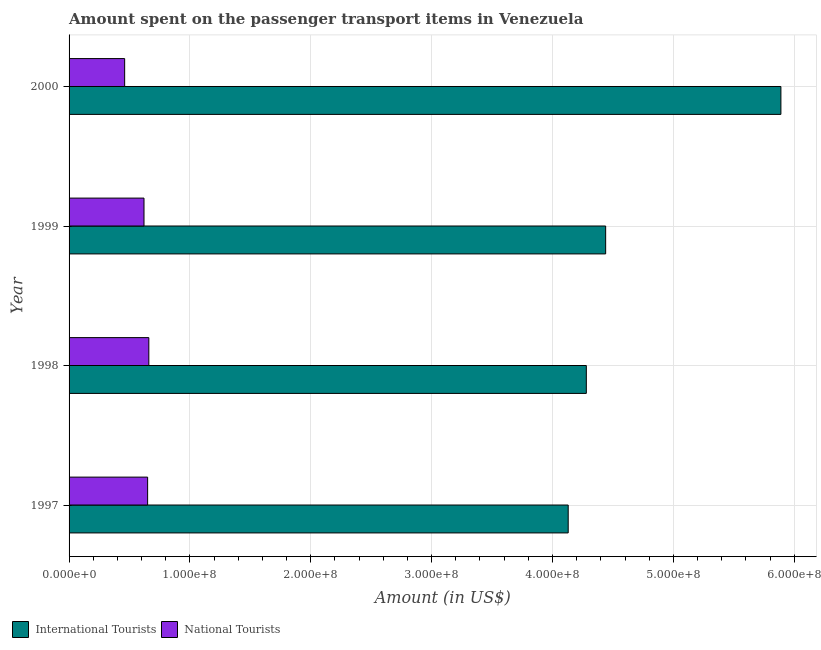How many different coloured bars are there?
Offer a very short reply. 2. How many groups of bars are there?
Your answer should be very brief. 4. Are the number of bars on each tick of the Y-axis equal?
Provide a short and direct response. Yes. How many bars are there on the 4th tick from the top?
Your answer should be very brief. 2. How many bars are there on the 2nd tick from the bottom?
Provide a short and direct response. 2. What is the label of the 2nd group of bars from the top?
Your answer should be very brief. 1999. What is the amount spent on transport items of international tourists in 2000?
Offer a terse response. 5.89e+08. Across all years, what is the maximum amount spent on transport items of national tourists?
Your response must be concise. 6.60e+07. Across all years, what is the minimum amount spent on transport items of national tourists?
Your answer should be compact. 4.60e+07. In which year was the amount spent on transport items of national tourists maximum?
Offer a terse response. 1998. In which year was the amount spent on transport items of international tourists minimum?
Your response must be concise. 1997. What is the total amount spent on transport items of national tourists in the graph?
Provide a short and direct response. 2.39e+08. What is the difference between the amount spent on transport items of national tourists in 1998 and that in 1999?
Ensure brevity in your answer.  4.00e+06. What is the difference between the amount spent on transport items of national tourists in 1997 and the amount spent on transport items of international tourists in 2000?
Your answer should be compact. -5.24e+08. What is the average amount spent on transport items of national tourists per year?
Keep it short and to the point. 5.98e+07. In the year 1997, what is the difference between the amount spent on transport items of international tourists and amount spent on transport items of national tourists?
Offer a terse response. 3.48e+08. What is the ratio of the amount spent on transport items of international tourists in 1999 to that in 2000?
Your answer should be compact. 0.75. Is the amount spent on transport items of national tourists in 1998 less than that in 1999?
Give a very brief answer. No. What is the difference between the highest and the second highest amount spent on transport items of international tourists?
Keep it short and to the point. 1.45e+08. What is the difference between the highest and the lowest amount spent on transport items of international tourists?
Your answer should be very brief. 1.76e+08. Is the sum of the amount spent on transport items of international tourists in 1999 and 2000 greater than the maximum amount spent on transport items of national tourists across all years?
Your answer should be compact. Yes. What does the 1st bar from the top in 1999 represents?
Your answer should be very brief. National Tourists. What does the 2nd bar from the bottom in 1999 represents?
Provide a succinct answer. National Tourists. How many years are there in the graph?
Keep it short and to the point. 4. Does the graph contain any zero values?
Provide a succinct answer. No. Where does the legend appear in the graph?
Your answer should be very brief. Bottom left. What is the title of the graph?
Provide a short and direct response. Amount spent on the passenger transport items in Venezuela. What is the Amount (in US$) in International Tourists in 1997?
Offer a terse response. 4.13e+08. What is the Amount (in US$) of National Tourists in 1997?
Provide a succinct answer. 6.50e+07. What is the Amount (in US$) in International Tourists in 1998?
Give a very brief answer. 4.28e+08. What is the Amount (in US$) of National Tourists in 1998?
Your response must be concise. 6.60e+07. What is the Amount (in US$) of International Tourists in 1999?
Keep it short and to the point. 4.44e+08. What is the Amount (in US$) in National Tourists in 1999?
Offer a very short reply. 6.20e+07. What is the Amount (in US$) in International Tourists in 2000?
Keep it short and to the point. 5.89e+08. What is the Amount (in US$) of National Tourists in 2000?
Your response must be concise. 4.60e+07. Across all years, what is the maximum Amount (in US$) of International Tourists?
Ensure brevity in your answer.  5.89e+08. Across all years, what is the maximum Amount (in US$) of National Tourists?
Your response must be concise. 6.60e+07. Across all years, what is the minimum Amount (in US$) of International Tourists?
Make the answer very short. 4.13e+08. Across all years, what is the minimum Amount (in US$) in National Tourists?
Your answer should be very brief. 4.60e+07. What is the total Amount (in US$) in International Tourists in the graph?
Give a very brief answer. 1.87e+09. What is the total Amount (in US$) in National Tourists in the graph?
Offer a very short reply. 2.39e+08. What is the difference between the Amount (in US$) in International Tourists in 1997 and that in 1998?
Give a very brief answer. -1.50e+07. What is the difference between the Amount (in US$) in International Tourists in 1997 and that in 1999?
Provide a short and direct response. -3.10e+07. What is the difference between the Amount (in US$) in National Tourists in 1997 and that in 1999?
Your answer should be compact. 3.00e+06. What is the difference between the Amount (in US$) of International Tourists in 1997 and that in 2000?
Your answer should be very brief. -1.76e+08. What is the difference between the Amount (in US$) of National Tourists in 1997 and that in 2000?
Make the answer very short. 1.90e+07. What is the difference between the Amount (in US$) of International Tourists in 1998 and that in 1999?
Make the answer very short. -1.60e+07. What is the difference between the Amount (in US$) of International Tourists in 1998 and that in 2000?
Offer a very short reply. -1.61e+08. What is the difference between the Amount (in US$) in National Tourists in 1998 and that in 2000?
Give a very brief answer. 2.00e+07. What is the difference between the Amount (in US$) of International Tourists in 1999 and that in 2000?
Make the answer very short. -1.45e+08. What is the difference between the Amount (in US$) of National Tourists in 1999 and that in 2000?
Make the answer very short. 1.60e+07. What is the difference between the Amount (in US$) of International Tourists in 1997 and the Amount (in US$) of National Tourists in 1998?
Offer a terse response. 3.47e+08. What is the difference between the Amount (in US$) of International Tourists in 1997 and the Amount (in US$) of National Tourists in 1999?
Offer a terse response. 3.51e+08. What is the difference between the Amount (in US$) in International Tourists in 1997 and the Amount (in US$) in National Tourists in 2000?
Ensure brevity in your answer.  3.67e+08. What is the difference between the Amount (in US$) in International Tourists in 1998 and the Amount (in US$) in National Tourists in 1999?
Offer a terse response. 3.66e+08. What is the difference between the Amount (in US$) of International Tourists in 1998 and the Amount (in US$) of National Tourists in 2000?
Give a very brief answer. 3.82e+08. What is the difference between the Amount (in US$) in International Tourists in 1999 and the Amount (in US$) in National Tourists in 2000?
Provide a succinct answer. 3.98e+08. What is the average Amount (in US$) in International Tourists per year?
Make the answer very short. 4.68e+08. What is the average Amount (in US$) of National Tourists per year?
Your answer should be compact. 5.98e+07. In the year 1997, what is the difference between the Amount (in US$) in International Tourists and Amount (in US$) in National Tourists?
Your answer should be very brief. 3.48e+08. In the year 1998, what is the difference between the Amount (in US$) in International Tourists and Amount (in US$) in National Tourists?
Provide a short and direct response. 3.62e+08. In the year 1999, what is the difference between the Amount (in US$) in International Tourists and Amount (in US$) in National Tourists?
Give a very brief answer. 3.82e+08. In the year 2000, what is the difference between the Amount (in US$) in International Tourists and Amount (in US$) in National Tourists?
Offer a terse response. 5.43e+08. What is the ratio of the Amount (in US$) in International Tourists in 1997 to that in 1998?
Keep it short and to the point. 0.96. What is the ratio of the Amount (in US$) of National Tourists in 1997 to that in 1998?
Ensure brevity in your answer.  0.98. What is the ratio of the Amount (in US$) in International Tourists in 1997 to that in 1999?
Keep it short and to the point. 0.93. What is the ratio of the Amount (in US$) of National Tourists in 1997 to that in 1999?
Offer a terse response. 1.05. What is the ratio of the Amount (in US$) in International Tourists in 1997 to that in 2000?
Your response must be concise. 0.7. What is the ratio of the Amount (in US$) in National Tourists in 1997 to that in 2000?
Your answer should be very brief. 1.41. What is the ratio of the Amount (in US$) in National Tourists in 1998 to that in 1999?
Your answer should be compact. 1.06. What is the ratio of the Amount (in US$) in International Tourists in 1998 to that in 2000?
Your answer should be very brief. 0.73. What is the ratio of the Amount (in US$) of National Tourists in 1998 to that in 2000?
Your response must be concise. 1.43. What is the ratio of the Amount (in US$) of International Tourists in 1999 to that in 2000?
Your answer should be very brief. 0.75. What is the ratio of the Amount (in US$) of National Tourists in 1999 to that in 2000?
Give a very brief answer. 1.35. What is the difference between the highest and the second highest Amount (in US$) of International Tourists?
Ensure brevity in your answer.  1.45e+08. What is the difference between the highest and the lowest Amount (in US$) of International Tourists?
Offer a very short reply. 1.76e+08. 